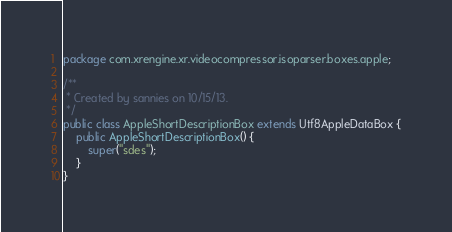Convert code to text. <code><loc_0><loc_0><loc_500><loc_500><_Java_>package com.xrengine.xr.videocompressor.isoparser.boxes.apple;

/**
 * Created by sannies on 10/15/13.
 */
public class AppleShortDescriptionBox extends Utf8AppleDataBox {
    public AppleShortDescriptionBox() {
        super("sdes");
    }
}
</code> 